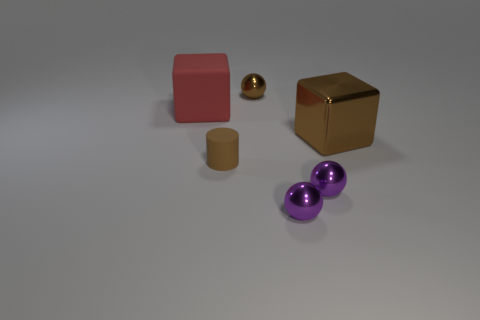Add 1 large green cubes. How many objects exist? 7 Subtract all cylinders. How many objects are left? 5 Add 4 tiny purple shiny spheres. How many tiny purple shiny spheres are left? 6 Add 4 cyan rubber cylinders. How many cyan rubber cylinders exist? 4 Subtract 0 cyan spheres. How many objects are left? 6 Subtract all big red shiny balls. Subtract all small brown metallic spheres. How many objects are left? 5 